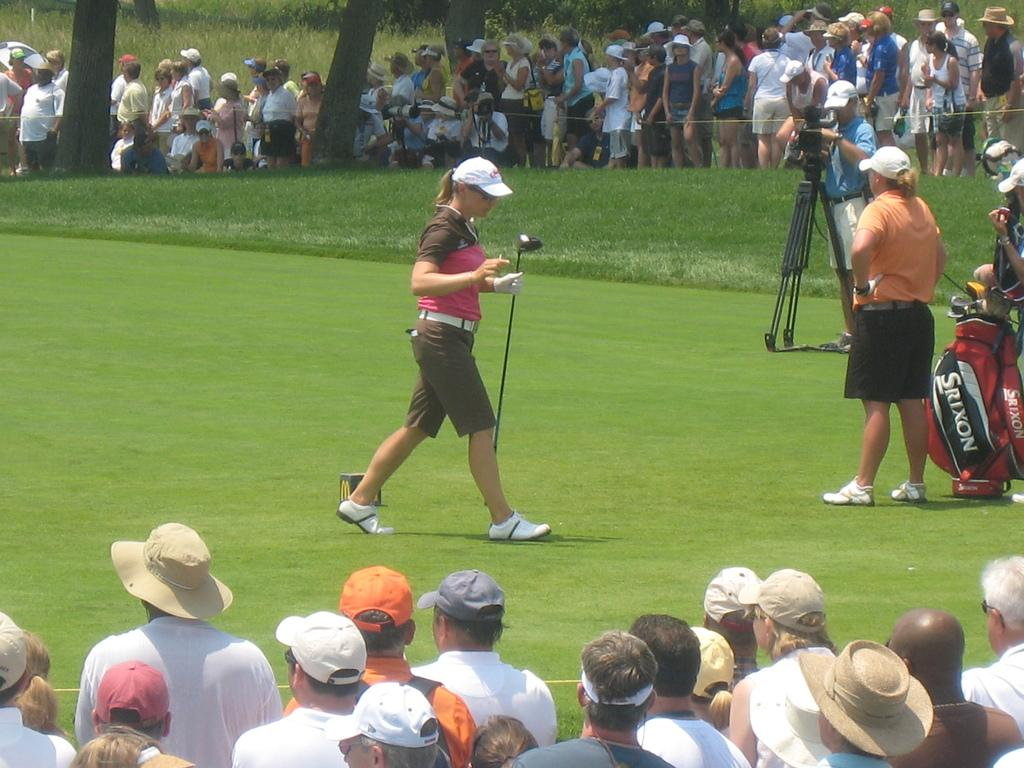<image>
Present a compact description of the photo's key features. A female golf player and a golf bag labelled Srixon. 